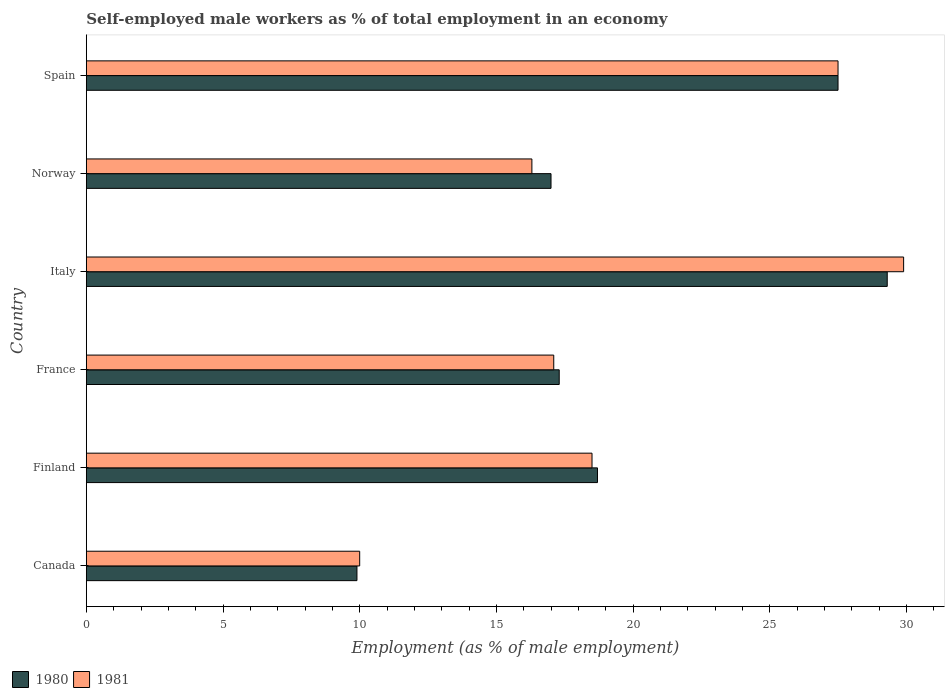Are the number of bars on each tick of the Y-axis equal?
Give a very brief answer. Yes. How many bars are there on the 5th tick from the bottom?
Your answer should be compact. 2. What is the label of the 2nd group of bars from the top?
Give a very brief answer. Norway. Across all countries, what is the maximum percentage of self-employed male workers in 1980?
Your answer should be very brief. 29.3. Across all countries, what is the minimum percentage of self-employed male workers in 1980?
Offer a terse response. 9.9. What is the total percentage of self-employed male workers in 1980 in the graph?
Give a very brief answer. 119.7. What is the difference between the percentage of self-employed male workers in 1981 in Finland and that in France?
Give a very brief answer. 1.4. What is the difference between the percentage of self-employed male workers in 1980 in Italy and the percentage of self-employed male workers in 1981 in France?
Your response must be concise. 12.2. What is the average percentage of self-employed male workers in 1980 per country?
Ensure brevity in your answer.  19.95. What is the difference between the percentage of self-employed male workers in 1980 and percentage of self-employed male workers in 1981 in Italy?
Give a very brief answer. -0.6. What is the ratio of the percentage of self-employed male workers in 1981 in Finland to that in Italy?
Your answer should be compact. 0.62. Is the percentage of self-employed male workers in 1980 in Canada less than that in Italy?
Make the answer very short. Yes. Is the difference between the percentage of self-employed male workers in 1980 in Canada and France greater than the difference between the percentage of self-employed male workers in 1981 in Canada and France?
Keep it short and to the point. No. What is the difference between the highest and the second highest percentage of self-employed male workers in 1981?
Your answer should be compact. 2.4. What is the difference between the highest and the lowest percentage of self-employed male workers in 1981?
Your response must be concise. 19.9. In how many countries, is the percentage of self-employed male workers in 1980 greater than the average percentage of self-employed male workers in 1980 taken over all countries?
Make the answer very short. 2. What does the 1st bar from the bottom in Spain represents?
Your response must be concise. 1980. How many bars are there?
Ensure brevity in your answer.  12. Are all the bars in the graph horizontal?
Make the answer very short. Yes. How many countries are there in the graph?
Keep it short and to the point. 6. What is the difference between two consecutive major ticks on the X-axis?
Provide a short and direct response. 5. Does the graph contain grids?
Your answer should be compact. No. What is the title of the graph?
Your answer should be very brief. Self-employed male workers as % of total employment in an economy. What is the label or title of the X-axis?
Provide a short and direct response. Employment (as % of male employment). What is the label or title of the Y-axis?
Ensure brevity in your answer.  Country. What is the Employment (as % of male employment) of 1980 in Canada?
Offer a very short reply. 9.9. What is the Employment (as % of male employment) of 1981 in Canada?
Your answer should be very brief. 10. What is the Employment (as % of male employment) of 1980 in Finland?
Your response must be concise. 18.7. What is the Employment (as % of male employment) in 1980 in France?
Your answer should be very brief. 17.3. What is the Employment (as % of male employment) in 1981 in France?
Give a very brief answer. 17.1. What is the Employment (as % of male employment) in 1980 in Italy?
Your answer should be compact. 29.3. What is the Employment (as % of male employment) in 1981 in Italy?
Keep it short and to the point. 29.9. What is the Employment (as % of male employment) of 1980 in Norway?
Keep it short and to the point. 17. What is the Employment (as % of male employment) of 1981 in Norway?
Make the answer very short. 16.3. Across all countries, what is the maximum Employment (as % of male employment) of 1980?
Provide a succinct answer. 29.3. Across all countries, what is the maximum Employment (as % of male employment) of 1981?
Keep it short and to the point. 29.9. Across all countries, what is the minimum Employment (as % of male employment) in 1980?
Your answer should be very brief. 9.9. What is the total Employment (as % of male employment) of 1980 in the graph?
Your response must be concise. 119.7. What is the total Employment (as % of male employment) of 1981 in the graph?
Your response must be concise. 119.3. What is the difference between the Employment (as % of male employment) in 1980 in Canada and that in Finland?
Your response must be concise. -8.8. What is the difference between the Employment (as % of male employment) in 1981 in Canada and that in Finland?
Your response must be concise. -8.5. What is the difference between the Employment (as % of male employment) in 1980 in Canada and that in France?
Give a very brief answer. -7.4. What is the difference between the Employment (as % of male employment) of 1980 in Canada and that in Italy?
Offer a very short reply. -19.4. What is the difference between the Employment (as % of male employment) of 1981 in Canada and that in Italy?
Make the answer very short. -19.9. What is the difference between the Employment (as % of male employment) of 1980 in Canada and that in Norway?
Your answer should be compact. -7.1. What is the difference between the Employment (as % of male employment) of 1981 in Canada and that in Norway?
Keep it short and to the point. -6.3. What is the difference between the Employment (as % of male employment) of 1980 in Canada and that in Spain?
Your answer should be very brief. -17.6. What is the difference between the Employment (as % of male employment) of 1981 in Canada and that in Spain?
Offer a terse response. -17.5. What is the difference between the Employment (as % of male employment) of 1980 in Finland and that in France?
Your answer should be compact. 1.4. What is the difference between the Employment (as % of male employment) of 1981 in Finland and that in France?
Your answer should be compact. 1.4. What is the difference between the Employment (as % of male employment) of 1980 in Finland and that in Italy?
Offer a very short reply. -10.6. What is the difference between the Employment (as % of male employment) in 1981 in Finland and that in Italy?
Give a very brief answer. -11.4. What is the difference between the Employment (as % of male employment) of 1980 in Finland and that in Norway?
Keep it short and to the point. 1.7. What is the difference between the Employment (as % of male employment) of 1981 in Finland and that in Norway?
Offer a very short reply. 2.2. What is the difference between the Employment (as % of male employment) of 1981 in Finland and that in Spain?
Your response must be concise. -9. What is the difference between the Employment (as % of male employment) in 1980 in France and that in Italy?
Provide a short and direct response. -12. What is the difference between the Employment (as % of male employment) in 1981 in France and that in Italy?
Ensure brevity in your answer.  -12.8. What is the difference between the Employment (as % of male employment) in 1980 in France and that in Norway?
Offer a terse response. 0.3. What is the difference between the Employment (as % of male employment) in 1981 in France and that in Norway?
Offer a very short reply. 0.8. What is the difference between the Employment (as % of male employment) in 1980 in France and that in Spain?
Your answer should be compact. -10.2. What is the difference between the Employment (as % of male employment) of 1980 in Norway and that in Spain?
Your answer should be very brief. -10.5. What is the difference between the Employment (as % of male employment) in 1981 in Norway and that in Spain?
Your answer should be compact. -11.2. What is the difference between the Employment (as % of male employment) of 1980 in Canada and the Employment (as % of male employment) of 1981 in Finland?
Your answer should be compact. -8.6. What is the difference between the Employment (as % of male employment) in 1980 in Canada and the Employment (as % of male employment) in 1981 in Norway?
Your answer should be compact. -6.4. What is the difference between the Employment (as % of male employment) of 1980 in Canada and the Employment (as % of male employment) of 1981 in Spain?
Your answer should be very brief. -17.6. What is the difference between the Employment (as % of male employment) of 1980 in Finland and the Employment (as % of male employment) of 1981 in France?
Keep it short and to the point. 1.6. What is the difference between the Employment (as % of male employment) in 1980 in Finland and the Employment (as % of male employment) in 1981 in Italy?
Offer a very short reply. -11.2. What is the difference between the Employment (as % of male employment) of 1980 in Finland and the Employment (as % of male employment) of 1981 in Spain?
Offer a terse response. -8.8. What is the average Employment (as % of male employment) in 1980 per country?
Your answer should be very brief. 19.95. What is the average Employment (as % of male employment) in 1981 per country?
Provide a short and direct response. 19.88. What is the difference between the Employment (as % of male employment) of 1980 and Employment (as % of male employment) of 1981 in Canada?
Give a very brief answer. -0.1. What is the difference between the Employment (as % of male employment) in 1980 and Employment (as % of male employment) in 1981 in Italy?
Offer a very short reply. -0.6. What is the ratio of the Employment (as % of male employment) of 1980 in Canada to that in Finland?
Offer a very short reply. 0.53. What is the ratio of the Employment (as % of male employment) in 1981 in Canada to that in Finland?
Make the answer very short. 0.54. What is the ratio of the Employment (as % of male employment) in 1980 in Canada to that in France?
Give a very brief answer. 0.57. What is the ratio of the Employment (as % of male employment) of 1981 in Canada to that in France?
Your answer should be compact. 0.58. What is the ratio of the Employment (as % of male employment) of 1980 in Canada to that in Italy?
Your answer should be very brief. 0.34. What is the ratio of the Employment (as % of male employment) of 1981 in Canada to that in Italy?
Offer a very short reply. 0.33. What is the ratio of the Employment (as % of male employment) of 1980 in Canada to that in Norway?
Offer a terse response. 0.58. What is the ratio of the Employment (as % of male employment) of 1981 in Canada to that in Norway?
Keep it short and to the point. 0.61. What is the ratio of the Employment (as % of male employment) in 1980 in Canada to that in Spain?
Keep it short and to the point. 0.36. What is the ratio of the Employment (as % of male employment) of 1981 in Canada to that in Spain?
Your answer should be very brief. 0.36. What is the ratio of the Employment (as % of male employment) of 1980 in Finland to that in France?
Your answer should be compact. 1.08. What is the ratio of the Employment (as % of male employment) in 1981 in Finland to that in France?
Ensure brevity in your answer.  1.08. What is the ratio of the Employment (as % of male employment) of 1980 in Finland to that in Italy?
Keep it short and to the point. 0.64. What is the ratio of the Employment (as % of male employment) of 1981 in Finland to that in Italy?
Ensure brevity in your answer.  0.62. What is the ratio of the Employment (as % of male employment) of 1981 in Finland to that in Norway?
Give a very brief answer. 1.14. What is the ratio of the Employment (as % of male employment) in 1980 in Finland to that in Spain?
Your answer should be very brief. 0.68. What is the ratio of the Employment (as % of male employment) of 1981 in Finland to that in Spain?
Your answer should be very brief. 0.67. What is the ratio of the Employment (as % of male employment) in 1980 in France to that in Italy?
Give a very brief answer. 0.59. What is the ratio of the Employment (as % of male employment) in 1981 in France to that in Italy?
Ensure brevity in your answer.  0.57. What is the ratio of the Employment (as % of male employment) in 1980 in France to that in Norway?
Ensure brevity in your answer.  1.02. What is the ratio of the Employment (as % of male employment) in 1981 in France to that in Norway?
Provide a short and direct response. 1.05. What is the ratio of the Employment (as % of male employment) of 1980 in France to that in Spain?
Provide a succinct answer. 0.63. What is the ratio of the Employment (as % of male employment) in 1981 in France to that in Spain?
Provide a short and direct response. 0.62. What is the ratio of the Employment (as % of male employment) in 1980 in Italy to that in Norway?
Give a very brief answer. 1.72. What is the ratio of the Employment (as % of male employment) in 1981 in Italy to that in Norway?
Provide a short and direct response. 1.83. What is the ratio of the Employment (as % of male employment) of 1980 in Italy to that in Spain?
Provide a succinct answer. 1.07. What is the ratio of the Employment (as % of male employment) of 1981 in Italy to that in Spain?
Your response must be concise. 1.09. What is the ratio of the Employment (as % of male employment) of 1980 in Norway to that in Spain?
Your answer should be compact. 0.62. What is the ratio of the Employment (as % of male employment) in 1981 in Norway to that in Spain?
Give a very brief answer. 0.59. What is the difference between the highest and the lowest Employment (as % of male employment) in 1980?
Your response must be concise. 19.4. 